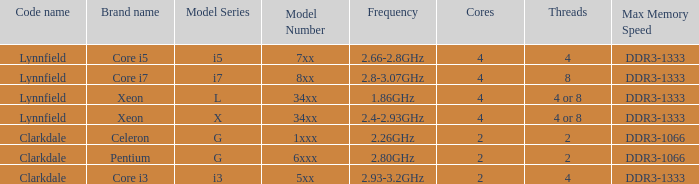What frequency does the Pentium processor use? 2.80GHz. 